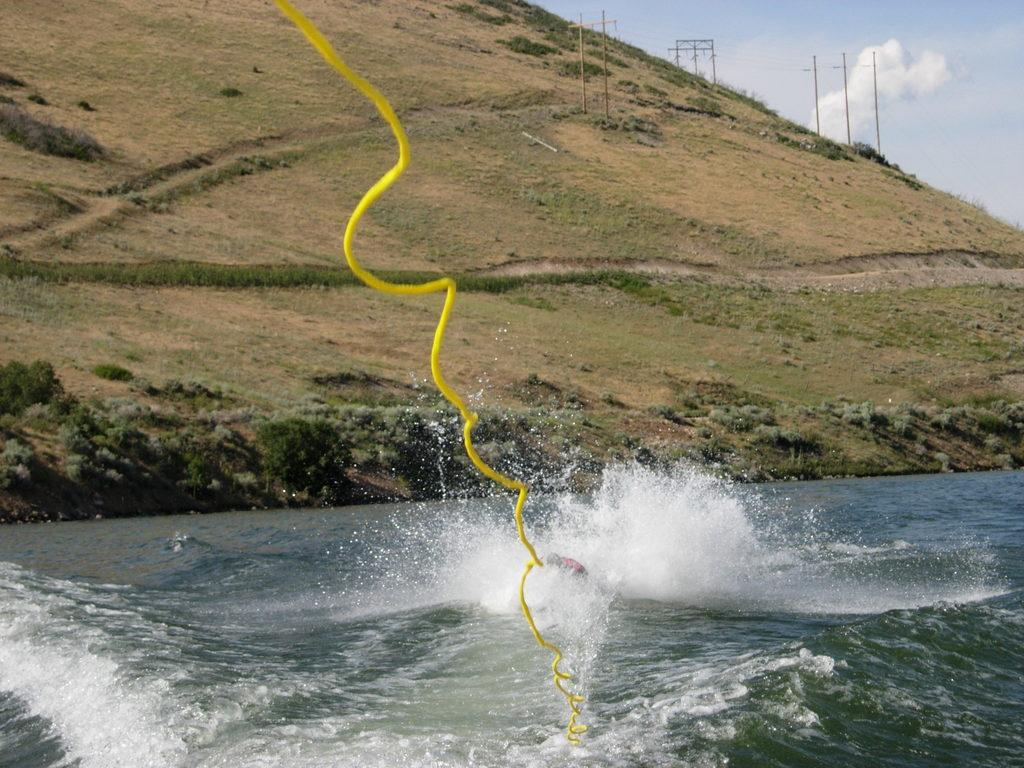What is present at the bottom of the image? There is water at the bottom of the image. What object can be seen in the image? There is a rope visible in the image. What can be seen in the distance in the image? There is a hill in the background of the image, along with poles. What part of the natural environment is visible in the image? The sky is visible in the image. What type of vegetation is present in the image? There are plants in the image. How does the beginner learn to twist the carriage in the image? There is no carriage or twisting in the image; it features water, a rope, a hill, poles, the sky, and plants. 